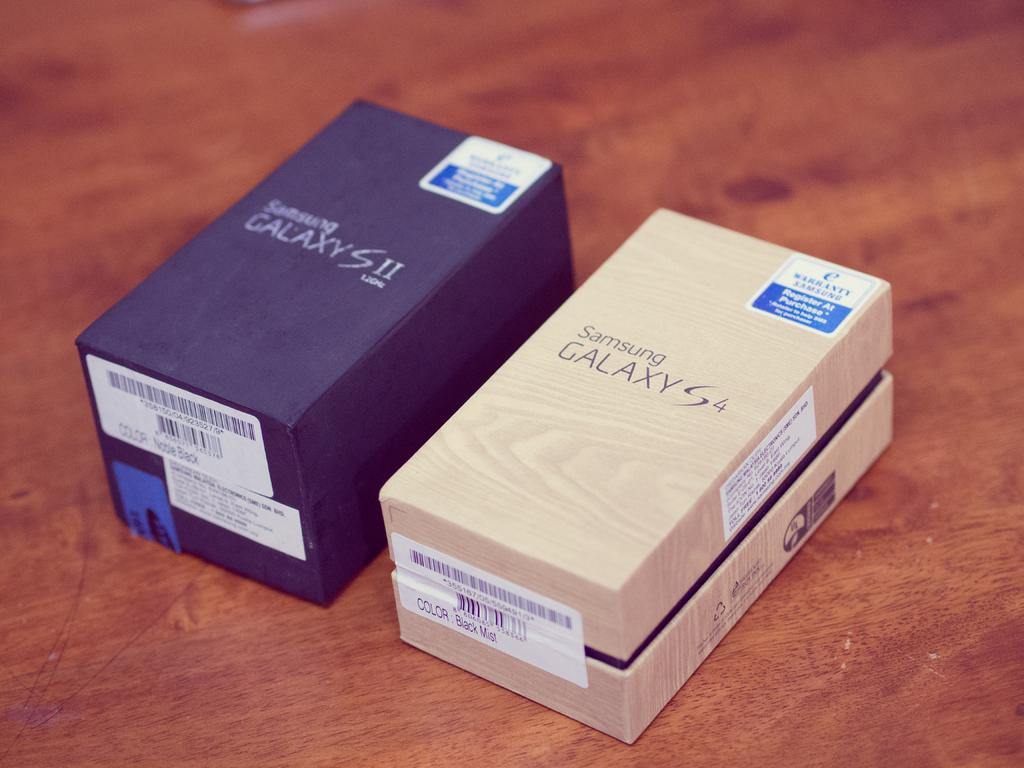<image>
Describe the image concisely. Two phone boxes side by side with one that says "Samsung GALAXY S4". 